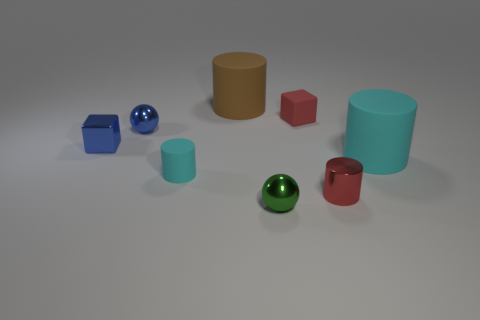Is the number of small cylinders behind the small red metal cylinder greater than the number of gray metallic balls? yes 